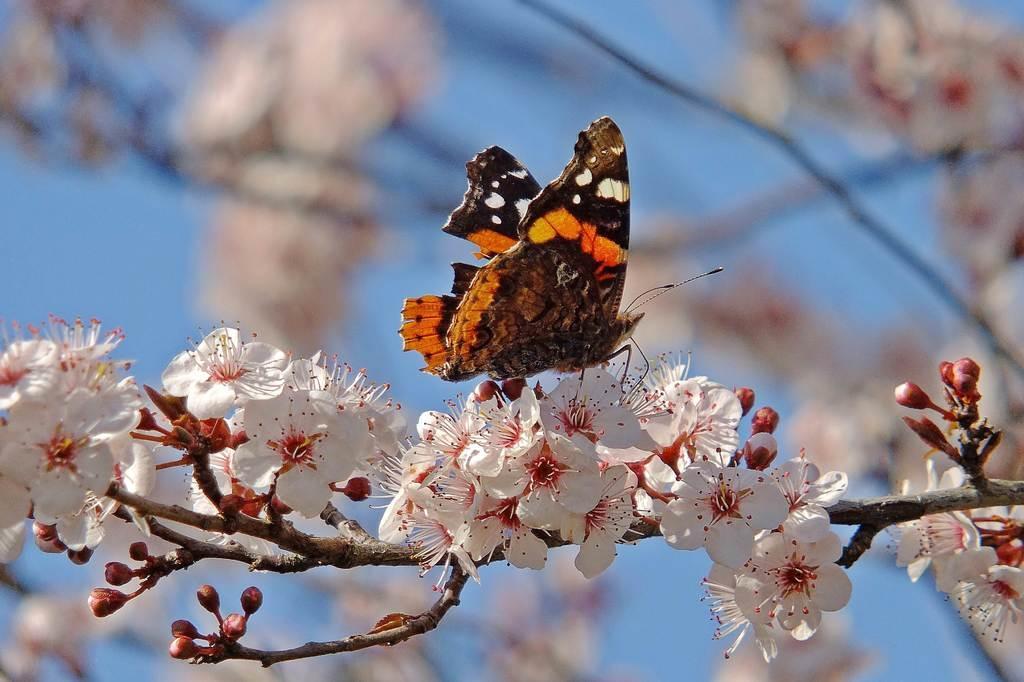Please provide a concise description of this image. In this image there is a butterfly on the flowers of a tree. In the background of the image there is sky. 